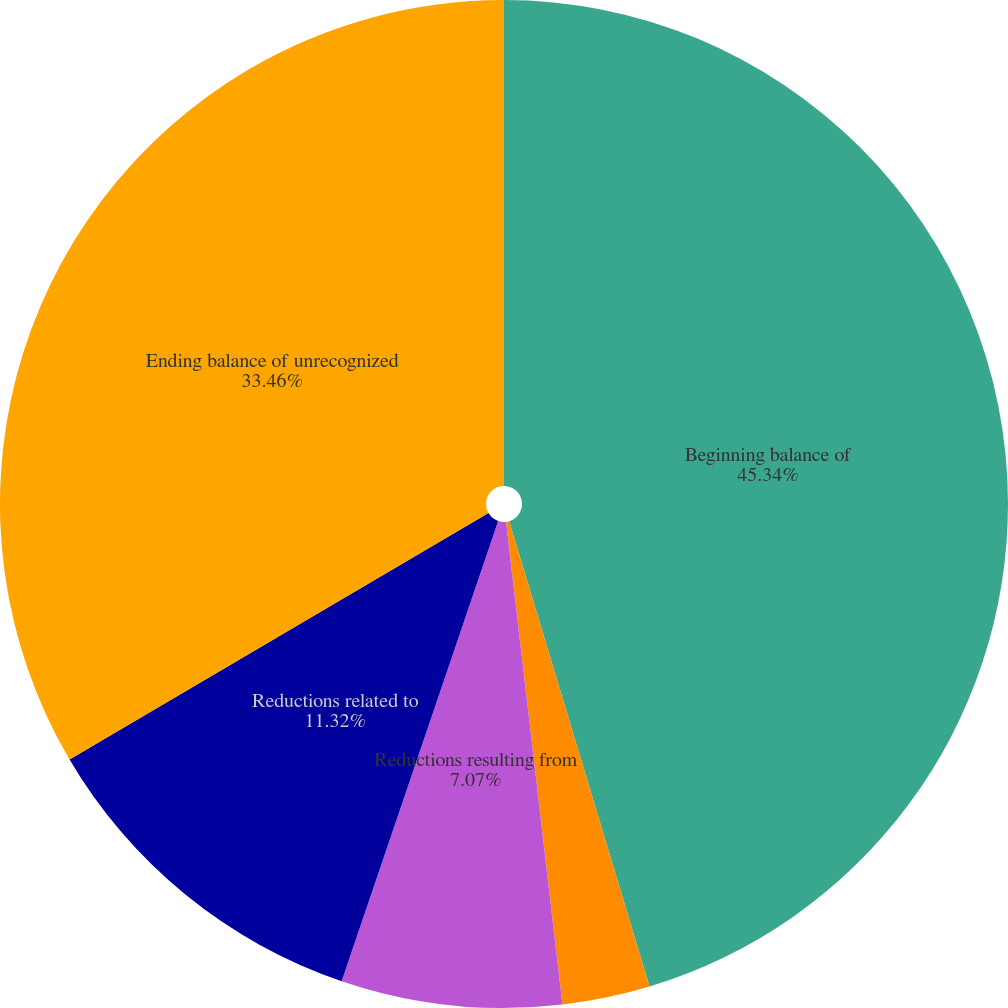<chart> <loc_0><loc_0><loc_500><loc_500><pie_chart><fcel>Beginning balance of<fcel>Additions based on tax<fcel>Reductions resulting from<fcel>Reductions related to<fcel>Ending balance of unrecognized<nl><fcel>45.34%<fcel>2.81%<fcel>7.07%<fcel>11.32%<fcel>33.46%<nl></chart> 